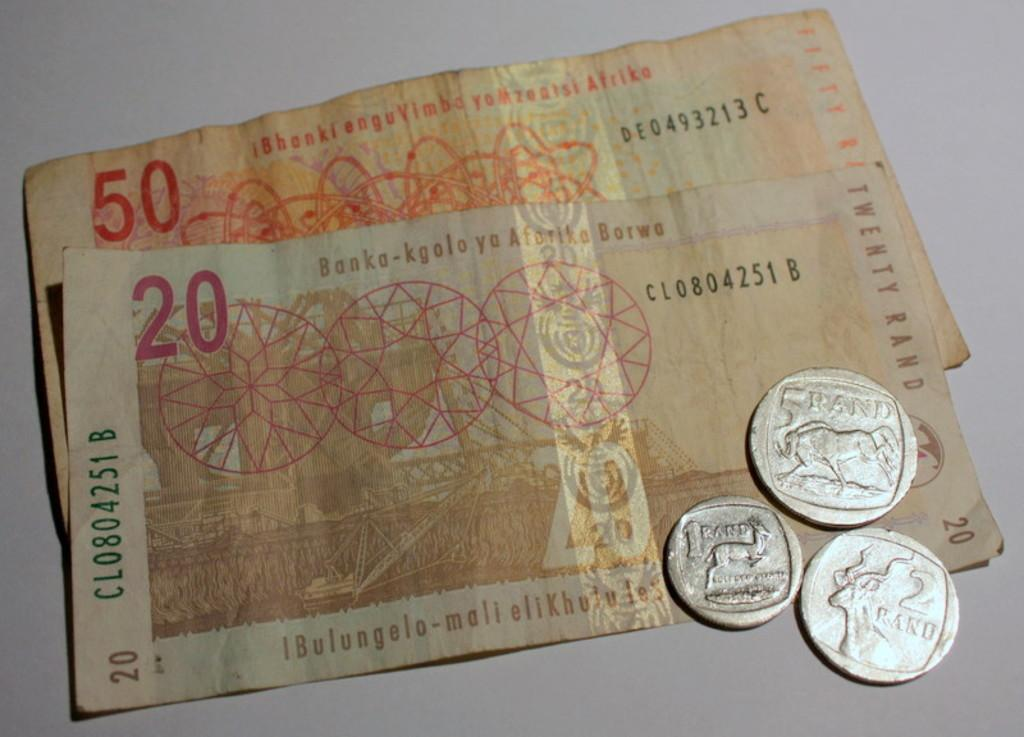What type of currency is present in the image? There is a 50 rupees note and a 20 rupees note in the image. Are there any coins in the image? Yes, there are three silver coins in the image. Where are the currency and coins located? The objects are kept on a table. What type of straw is being used by the person in the image? There is no person present in the image, and therefore no straw can be observed. 